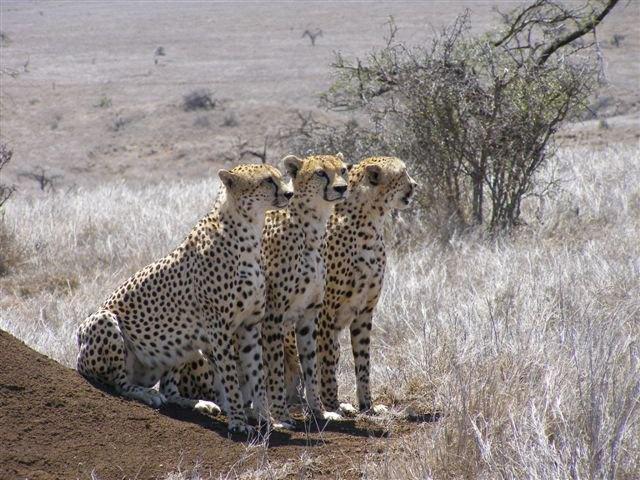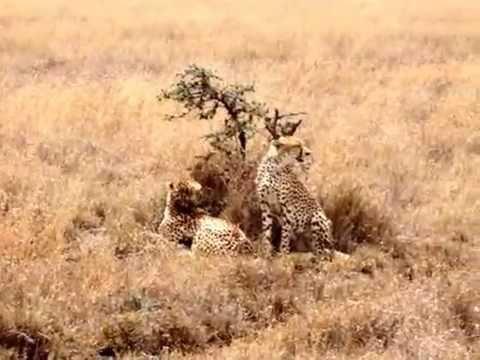The first image is the image on the left, the second image is the image on the right. For the images shown, is this caption "There is at least two cheetahs in the left image." true? Answer yes or no. Yes. The first image is the image on the left, the second image is the image on the right. Given the left and right images, does the statement "One image includes three cheetahs of the same size sitting upright in a row in lookalike poses." hold true? Answer yes or no. Yes. 